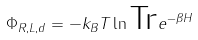<formula> <loc_0><loc_0><loc_500><loc_500>\Phi _ { R , L , d } = - k _ { B } T \ln \text {Tr} e ^ { - \beta H }</formula> 